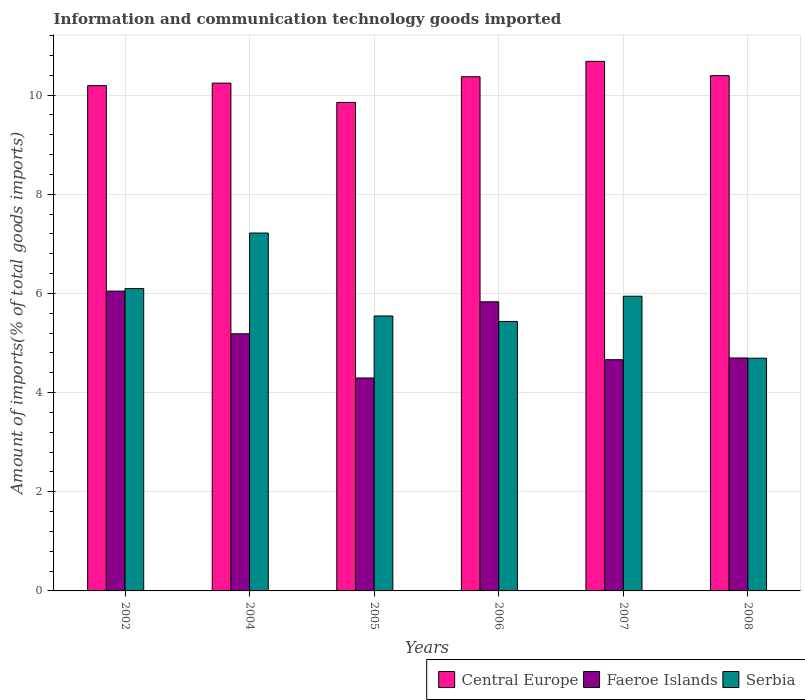Are the number of bars on each tick of the X-axis equal?
Make the answer very short. Yes. How many bars are there on the 5th tick from the left?
Your answer should be compact. 3. How many bars are there on the 2nd tick from the right?
Ensure brevity in your answer.  3. What is the amount of goods imported in Central Europe in 2005?
Provide a succinct answer. 9.85. Across all years, what is the maximum amount of goods imported in Central Europe?
Offer a very short reply. 10.68. Across all years, what is the minimum amount of goods imported in Faeroe Islands?
Give a very brief answer. 4.29. In which year was the amount of goods imported in Central Europe maximum?
Offer a very short reply. 2007. What is the total amount of goods imported in Serbia in the graph?
Your answer should be very brief. 34.94. What is the difference between the amount of goods imported in Faeroe Islands in 2007 and that in 2008?
Provide a short and direct response. -0.04. What is the difference between the amount of goods imported in Serbia in 2008 and the amount of goods imported in Central Europe in 2005?
Ensure brevity in your answer.  -5.16. What is the average amount of goods imported in Faeroe Islands per year?
Provide a short and direct response. 5.12. In the year 2006, what is the difference between the amount of goods imported in Faeroe Islands and amount of goods imported in Central Europe?
Make the answer very short. -4.54. In how many years, is the amount of goods imported in Serbia greater than 4.4 %?
Your answer should be very brief. 6. What is the ratio of the amount of goods imported in Serbia in 2006 to that in 2007?
Keep it short and to the point. 0.91. What is the difference between the highest and the second highest amount of goods imported in Serbia?
Your answer should be compact. 1.12. What is the difference between the highest and the lowest amount of goods imported in Central Europe?
Your response must be concise. 0.83. Is the sum of the amount of goods imported in Central Europe in 2002 and 2005 greater than the maximum amount of goods imported in Faeroe Islands across all years?
Keep it short and to the point. Yes. What does the 1st bar from the left in 2006 represents?
Provide a succinct answer. Central Europe. What does the 3rd bar from the right in 2002 represents?
Your answer should be compact. Central Europe. How many bars are there?
Provide a short and direct response. 18. What is the difference between two consecutive major ticks on the Y-axis?
Keep it short and to the point. 2. Does the graph contain grids?
Provide a succinct answer. Yes. Where does the legend appear in the graph?
Give a very brief answer. Bottom right. What is the title of the graph?
Provide a short and direct response. Information and communication technology goods imported. Does "Malta" appear as one of the legend labels in the graph?
Ensure brevity in your answer.  No. What is the label or title of the Y-axis?
Your answer should be compact. Amount of imports(% of total goods imports). What is the Amount of imports(% of total goods imports) of Central Europe in 2002?
Your response must be concise. 10.19. What is the Amount of imports(% of total goods imports) of Faeroe Islands in 2002?
Provide a succinct answer. 6.05. What is the Amount of imports(% of total goods imports) of Serbia in 2002?
Ensure brevity in your answer.  6.1. What is the Amount of imports(% of total goods imports) in Central Europe in 2004?
Make the answer very short. 10.24. What is the Amount of imports(% of total goods imports) of Faeroe Islands in 2004?
Provide a short and direct response. 5.19. What is the Amount of imports(% of total goods imports) in Serbia in 2004?
Your response must be concise. 7.22. What is the Amount of imports(% of total goods imports) of Central Europe in 2005?
Ensure brevity in your answer.  9.85. What is the Amount of imports(% of total goods imports) in Faeroe Islands in 2005?
Your answer should be very brief. 4.29. What is the Amount of imports(% of total goods imports) in Serbia in 2005?
Make the answer very short. 5.55. What is the Amount of imports(% of total goods imports) in Central Europe in 2006?
Offer a terse response. 10.37. What is the Amount of imports(% of total goods imports) in Faeroe Islands in 2006?
Make the answer very short. 5.83. What is the Amount of imports(% of total goods imports) of Serbia in 2006?
Your response must be concise. 5.44. What is the Amount of imports(% of total goods imports) of Central Europe in 2007?
Provide a short and direct response. 10.68. What is the Amount of imports(% of total goods imports) in Faeroe Islands in 2007?
Offer a very short reply. 4.66. What is the Amount of imports(% of total goods imports) of Serbia in 2007?
Your answer should be very brief. 5.94. What is the Amount of imports(% of total goods imports) of Central Europe in 2008?
Offer a very short reply. 10.39. What is the Amount of imports(% of total goods imports) in Faeroe Islands in 2008?
Offer a terse response. 4.7. What is the Amount of imports(% of total goods imports) of Serbia in 2008?
Your answer should be compact. 4.69. Across all years, what is the maximum Amount of imports(% of total goods imports) in Central Europe?
Your response must be concise. 10.68. Across all years, what is the maximum Amount of imports(% of total goods imports) in Faeroe Islands?
Ensure brevity in your answer.  6.05. Across all years, what is the maximum Amount of imports(% of total goods imports) of Serbia?
Keep it short and to the point. 7.22. Across all years, what is the minimum Amount of imports(% of total goods imports) in Central Europe?
Offer a very short reply. 9.85. Across all years, what is the minimum Amount of imports(% of total goods imports) in Faeroe Islands?
Your answer should be compact. 4.29. Across all years, what is the minimum Amount of imports(% of total goods imports) in Serbia?
Your response must be concise. 4.69. What is the total Amount of imports(% of total goods imports) of Central Europe in the graph?
Provide a short and direct response. 61.73. What is the total Amount of imports(% of total goods imports) in Faeroe Islands in the graph?
Ensure brevity in your answer.  30.72. What is the total Amount of imports(% of total goods imports) in Serbia in the graph?
Provide a succinct answer. 34.94. What is the difference between the Amount of imports(% of total goods imports) of Central Europe in 2002 and that in 2004?
Your response must be concise. -0.05. What is the difference between the Amount of imports(% of total goods imports) in Faeroe Islands in 2002 and that in 2004?
Provide a succinct answer. 0.86. What is the difference between the Amount of imports(% of total goods imports) in Serbia in 2002 and that in 2004?
Provide a short and direct response. -1.12. What is the difference between the Amount of imports(% of total goods imports) in Central Europe in 2002 and that in 2005?
Your answer should be very brief. 0.34. What is the difference between the Amount of imports(% of total goods imports) of Faeroe Islands in 2002 and that in 2005?
Offer a terse response. 1.75. What is the difference between the Amount of imports(% of total goods imports) of Serbia in 2002 and that in 2005?
Your answer should be compact. 0.55. What is the difference between the Amount of imports(% of total goods imports) of Central Europe in 2002 and that in 2006?
Provide a succinct answer. -0.18. What is the difference between the Amount of imports(% of total goods imports) in Faeroe Islands in 2002 and that in 2006?
Provide a short and direct response. 0.22. What is the difference between the Amount of imports(% of total goods imports) in Serbia in 2002 and that in 2006?
Give a very brief answer. 0.66. What is the difference between the Amount of imports(% of total goods imports) of Central Europe in 2002 and that in 2007?
Make the answer very short. -0.49. What is the difference between the Amount of imports(% of total goods imports) of Faeroe Islands in 2002 and that in 2007?
Your answer should be very brief. 1.38. What is the difference between the Amount of imports(% of total goods imports) of Serbia in 2002 and that in 2007?
Your answer should be very brief. 0.15. What is the difference between the Amount of imports(% of total goods imports) in Central Europe in 2002 and that in 2008?
Your answer should be compact. -0.2. What is the difference between the Amount of imports(% of total goods imports) of Faeroe Islands in 2002 and that in 2008?
Provide a short and direct response. 1.35. What is the difference between the Amount of imports(% of total goods imports) of Serbia in 2002 and that in 2008?
Your answer should be very brief. 1.4. What is the difference between the Amount of imports(% of total goods imports) of Central Europe in 2004 and that in 2005?
Ensure brevity in your answer.  0.39. What is the difference between the Amount of imports(% of total goods imports) in Faeroe Islands in 2004 and that in 2005?
Provide a short and direct response. 0.89. What is the difference between the Amount of imports(% of total goods imports) of Serbia in 2004 and that in 2005?
Keep it short and to the point. 1.67. What is the difference between the Amount of imports(% of total goods imports) of Central Europe in 2004 and that in 2006?
Keep it short and to the point. -0.13. What is the difference between the Amount of imports(% of total goods imports) in Faeroe Islands in 2004 and that in 2006?
Ensure brevity in your answer.  -0.65. What is the difference between the Amount of imports(% of total goods imports) in Serbia in 2004 and that in 2006?
Provide a succinct answer. 1.78. What is the difference between the Amount of imports(% of total goods imports) of Central Europe in 2004 and that in 2007?
Your answer should be very brief. -0.44. What is the difference between the Amount of imports(% of total goods imports) of Faeroe Islands in 2004 and that in 2007?
Keep it short and to the point. 0.52. What is the difference between the Amount of imports(% of total goods imports) of Serbia in 2004 and that in 2007?
Your answer should be very brief. 1.27. What is the difference between the Amount of imports(% of total goods imports) of Central Europe in 2004 and that in 2008?
Keep it short and to the point. -0.15. What is the difference between the Amount of imports(% of total goods imports) in Faeroe Islands in 2004 and that in 2008?
Your response must be concise. 0.49. What is the difference between the Amount of imports(% of total goods imports) in Serbia in 2004 and that in 2008?
Keep it short and to the point. 2.52. What is the difference between the Amount of imports(% of total goods imports) of Central Europe in 2005 and that in 2006?
Your response must be concise. -0.52. What is the difference between the Amount of imports(% of total goods imports) in Faeroe Islands in 2005 and that in 2006?
Offer a very short reply. -1.54. What is the difference between the Amount of imports(% of total goods imports) of Serbia in 2005 and that in 2006?
Your answer should be very brief. 0.11. What is the difference between the Amount of imports(% of total goods imports) of Central Europe in 2005 and that in 2007?
Ensure brevity in your answer.  -0.83. What is the difference between the Amount of imports(% of total goods imports) of Faeroe Islands in 2005 and that in 2007?
Give a very brief answer. -0.37. What is the difference between the Amount of imports(% of total goods imports) in Serbia in 2005 and that in 2007?
Offer a terse response. -0.4. What is the difference between the Amount of imports(% of total goods imports) of Central Europe in 2005 and that in 2008?
Your answer should be very brief. -0.54. What is the difference between the Amount of imports(% of total goods imports) of Faeroe Islands in 2005 and that in 2008?
Make the answer very short. -0.4. What is the difference between the Amount of imports(% of total goods imports) in Serbia in 2005 and that in 2008?
Provide a short and direct response. 0.85. What is the difference between the Amount of imports(% of total goods imports) in Central Europe in 2006 and that in 2007?
Your answer should be very brief. -0.31. What is the difference between the Amount of imports(% of total goods imports) in Faeroe Islands in 2006 and that in 2007?
Keep it short and to the point. 1.17. What is the difference between the Amount of imports(% of total goods imports) in Serbia in 2006 and that in 2007?
Your answer should be compact. -0.51. What is the difference between the Amount of imports(% of total goods imports) in Central Europe in 2006 and that in 2008?
Keep it short and to the point. -0.02. What is the difference between the Amount of imports(% of total goods imports) of Faeroe Islands in 2006 and that in 2008?
Your answer should be compact. 1.13. What is the difference between the Amount of imports(% of total goods imports) of Serbia in 2006 and that in 2008?
Provide a succinct answer. 0.74. What is the difference between the Amount of imports(% of total goods imports) in Central Europe in 2007 and that in 2008?
Your response must be concise. 0.29. What is the difference between the Amount of imports(% of total goods imports) in Faeroe Islands in 2007 and that in 2008?
Make the answer very short. -0.04. What is the difference between the Amount of imports(% of total goods imports) of Serbia in 2007 and that in 2008?
Offer a terse response. 1.25. What is the difference between the Amount of imports(% of total goods imports) in Central Europe in 2002 and the Amount of imports(% of total goods imports) in Faeroe Islands in 2004?
Offer a very short reply. 5. What is the difference between the Amount of imports(% of total goods imports) in Central Europe in 2002 and the Amount of imports(% of total goods imports) in Serbia in 2004?
Make the answer very short. 2.97. What is the difference between the Amount of imports(% of total goods imports) in Faeroe Islands in 2002 and the Amount of imports(% of total goods imports) in Serbia in 2004?
Keep it short and to the point. -1.17. What is the difference between the Amount of imports(% of total goods imports) in Central Europe in 2002 and the Amount of imports(% of total goods imports) in Faeroe Islands in 2005?
Your answer should be compact. 5.9. What is the difference between the Amount of imports(% of total goods imports) of Central Europe in 2002 and the Amount of imports(% of total goods imports) of Serbia in 2005?
Offer a terse response. 4.65. What is the difference between the Amount of imports(% of total goods imports) of Faeroe Islands in 2002 and the Amount of imports(% of total goods imports) of Serbia in 2005?
Make the answer very short. 0.5. What is the difference between the Amount of imports(% of total goods imports) of Central Europe in 2002 and the Amount of imports(% of total goods imports) of Faeroe Islands in 2006?
Your answer should be very brief. 4.36. What is the difference between the Amount of imports(% of total goods imports) in Central Europe in 2002 and the Amount of imports(% of total goods imports) in Serbia in 2006?
Keep it short and to the point. 4.76. What is the difference between the Amount of imports(% of total goods imports) in Faeroe Islands in 2002 and the Amount of imports(% of total goods imports) in Serbia in 2006?
Your response must be concise. 0.61. What is the difference between the Amount of imports(% of total goods imports) in Central Europe in 2002 and the Amount of imports(% of total goods imports) in Faeroe Islands in 2007?
Your answer should be very brief. 5.53. What is the difference between the Amount of imports(% of total goods imports) of Central Europe in 2002 and the Amount of imports(% of total goods imports) of Serbia in 2007?
Provide a succinct answer. 4.25. What is the difference between the Amount of imports(% of total goods imports) of Faeroe Islands in 2002 and the Amount of imports(% of total goods imports) of Serbia in 2007?
Make the answer very short. 0.1. What is the difference between the Amount of imports(% of total goods imports) in Central Europe in 2002 and the Amount of imports(% of total goods imports) in Faeroe Islands in 2008?
Your answer should be compact. 5.49. What is the difference between the Amount of imports(% of total goods imports) of Central Europe in 2002 and the Amount of imports(% of total goods imports) of Serbia in 2008?
Your answer should be very brief. 5.5. What is the difference between the Amount of imports(% of total goods imports) in Faeroe Islands in 2002 and the Amount of imports(% of total goods imports) in Serbia in 2008?
Give a very brief answer. 1.35. What is the difference between the Amount of imports(% of total goods imports) in Central Europe in 2004 and the Amount of imports(% of total goods imports) in Faeroe Islands in 2005?
Make the answer very short. 5.95. What is the difference between the Amount of imports(% of total goods imports) of Central Europe in 2004 and the Amount of imports(% of total goods imports) of Serbia in 2005?
Ensure brevity in your answer.  4.7. What is the difference between the Amount of imports(% of total goods imports) of Faeroe Islands in 2004 and the Amount of imports(% of total goods imports) of Serbia in 2005?
Your answer should be very brief. -0.36. What is the difference between the Amount of imports(% of total goods imports) of Central Europe in 2004 and the Amount of imports(% of total goods imports) of Faeroe Islands in 2006?
Provide a succinct answer. 4.41. What is the difference between the Amount of imports(% of total goods imports) in Central Europe in 2004 and the Amount of imports(% of total goods imports) in Serbia in 2006?
Your answer should be very brief. 4.81. What is the difference between the Amount of imports(% of total goods imports) of Faeroe Islands in 2004 and the Amount of imports(% of total goods imports) of Serbia in 2006?
Ensure brevity in your answer.  -0.25. What is the difference between the Amount of imports(% of total goods imports) in Central Europe in 2004 and the Amount of imports(% of total goods imports) in Faeroe Islands in 2007?
Ensure brevity in your answer.  5.58. What is the difference between the Amount of imports(% of total goods imports) in Central Europe in 2004 and the Amount of imports(% of total goods imports) in Serbia in 2007?
Your answer should be very brief. 4.3. What is the difference between the Amount of imports(% of total goods imports) of Faeroe Islands in 2004 and the Amount of imports(% of total goods imports) of Serbia in 2007?
Give a very brief answer. -0.76. What is the difference between the Amount of imports(% of total goods imports) of Central Europe in 2004 and the Amount of imports(% of total goods imports) of Faeroe Islands in 2008?
Your answer should be very brief. 5.54. What is the difference between the Amount of imports(% of total goods imports) of Central Europe in 2004 and the Amount of imports(% of total goods imports) of Serbia in 2008?
Provide a short and direct response. 5.55. What is the difference between the Amount of imports(% of total goods imports) in Faeroe Islands in 2004 and the Amount of imports(% of total goods imports) in Serbia in 2008?
Provide a succinct answer. 0.49. What is the difference between the Amount of imports(% of total goods imports) of Central Europe in 2005 and the Amount of imports(% of total goods imports) of Faeroe Islands in 2006?
Ensure brevity in your answer.  4.02. What is the difference between the Amount of imports(% of total goods imports) in Central Europe in 2005 and the Amount of imports(% of total goods imports) in Serbia in 2006?
Offer a very short reply. 4.42. What is the difference between the Amount of imports(% of total goods imports) in Faeroe Islands in 2005 and the Amount of imports(% of total goods imports) in Serbia in 2006?
Give a very brief answer. -1.14. What is the difference between the Amount of imports(% of total goods imports) in Central Europe in 2005 and the Amount of imports(% of total goods imports) in Faeroe Islands in 2007?
Provide a succinct answer. 5.19. What is the difference between the Amount of imports(% of total goods imports) in Central Europe in 2005 and the Amount of imports(% of total goods imports) in Serbia in 2007?
Your answer should be very brief. 3.91. What is the difference between the Amount of imports(% of total goods imports) in Faeroe Islands in 2005 and the Amount of imports(% of total goods imports) in Serbia in 2007?
Keep it short and to the point. -1.65. What is the difference between the Amount of imports(% of total goods imports) of Central Europe in 2005 and the Amount of imports(% of total goods imports) of Faeroe Islands in 2008?
Your answer should be compact. 5.15. What is the difference between the Amount of imports(% of total goods imports) of Central Europe in 2005 and the Amount of imports(% of total goods imports) of Serbia in 2008?
Keep it short and to the point. 5.16. What is the difference between the Amount of imports(% of total goods imports) of Faeroe Islands in 2005 and the Amount of imports(% of total goods imports) of Serbia in 2008?
Give a very brief answer. -0.4. What is the difference between the Amount of imports(% of total goods imports) in Central Europe in 2006 and the Amount of imports(% of total goods imports) in Faeroe Islands in 2007?
Offer a terse response. 5.71. What is the difference between the Amount of imports(% of total goods imports) of Central Europe in 2006 and the Amount of imports(% of total goods imports) of Serbia in 2007?
Your answer should be very brief. 4.43. What is the difference between the Amount of imports(% of total goods imports) of Faeroe Islands in 2006 and the Amount of imports(% of total goods imports) of Serbia in 2007?
Your answer should be very brief. -0.11. What is the difference between the Amount of imports(% of total goods imports) in Central Europe in 2006 and the Amount of imports(% of total goods imports) in Faeroe Islands in 2008?
Keep it short and to the point. 5.67. What is the difference between the Amount of imports(% of total goods imports) in Central Europe in 2006 and the Amount of imports(% of total goods imports) in Serbia in 2008?
Make the answer very short. 5.68. What is the difference between the Amount of imports(% of total goods imports) in Faeroe Islands in 2006 and the Amount of imports(% of total goods imports) in Serbia in 2008?
Provide a succinct answer. 1.14. What is the difference between the Amount of imports(% of total goods imports) in Central Europe in 2007 and the Amount of imports(% of total goods imports) in Faeroe Islands in 2008?
Give a very brief answer. 5.98. What is the difference between the Amount of imports(% of total goods imports) of Central Europe in 2007 and the Amount of imports(% of total goods imports) of Serbia in 2008?
Make the answer very short. 5.99. What is the difference between the Amount of imports(% of total goods imports) in Faeroe Islands in 2007 and the Amount of imports(% of total goods imports) in Serbia in 2008?
Make the answer very short. -0.03. What is the average Amount of imports(% of total goods imports) in Central Europe per year?
Keep it short and to the point. 10.29. What is the average Amount of imports(% of total goods imports) in Faeroe Islands per year?
Give a very brief answer. 5.12. What is the average Amount of imports(% of total goods imports) of Serbia per year?
Your answer should be compact. 5.82. In the year 2002, what is the difference between the Amount of imports(% of total goods imports) of Central Europe and Amount of imports(% of total goods imports) of Faeroe Islands?
Give a very brief answer. 4.14. In the year 2002, what is the difference between the Amount of imports(% of total goods imports) in Central Europe and Amount of imports(% of total goods imports) in Serbia?
Provide a short and direct response. 4.09. In the year 2002, what is the difference between the Amount of imports(% of total goods imports) of Faeroe Islands and Amount of imports(% of total goods imports) of Serbia?
Provide a short and direct response. -0.05. In the year 2004, what is the difference between the Amount of imports(% of total goods imports) of Central Europe and Amount of imports(% of total goods imports) of Faeroe Islands?
Make the answer very short. 5.06. In the year 2004, what is the difference between the Amount of imports(% of total goods imports) of Central Europe and Amount of imports(% of total goods imports) of Serbia?
Your answer should be compact. 3.02. In the year 2004, what is the difference between the Amount of imports(% of total goods imports) of Faeroe Islands and Amount of imports(% of total goods imports) of Serbia?
Ensure brevity in your answer.  -2.03. In the year 2005, what is the difference between the Amount of imports(% of total goods imports) in Central Europe and Amount of imports(% of total goods imports) in Faeroe Islands?
Provide a succinct answer. 5.56. In the year 2005, what is the difference between the Amount of imports(% of total goods imports) of Central Europe and Amount of imports(% of total goods imports) of Serbia?
Make the answer very short. 4.31. In the year 2005, what is the difference between the Amount of imports(% of total goods imports) of Faeroe Islands and Amount of imports(% of total goods imports) of Serbia?
Provide a short and direct response. -1.25. In the year 2006, what is the difference between the Amount of imports(% of total goods imports) of Central Europe and Amount of imports(% of total goods imports) of Faeroe Islands?
Offer a terse response. 4.54. In the year 2006, what is the difference between the Amount of imports(% of total goods imports) of Central Europe and Amount of imports(% of total goods imports) of Serbia?
Offer a very short reply. 4.94. In the year 2006, what is the difference between the Amount of imports(% of total goods imports) in Faeroe Islands and Amount of imports(% of total goods imports) in Serbia?
Ensure brevity in your answer.  0.4. In the year 2007, what is the difference between the Amount of imports(% of total goods imports) in Central Europe and Amount of imports(% of total goods imports) in Faeroe Islands?
Your response must be concise. 6.02. In the year 2007, what is the difference between the Amount of imports(% of total goods imports) of Central Europe and Amount of imports(% of total goods imports) of Serbia?
Your response must be concise. 4.74. In the year 2007, what is the difference between the Amount of imports(% of total goods imports) in Faeroe Islands and Amount of imports(% of total goods imports) in Serbia?
Ensure brevity in your answer.  -1.28. In the year 2008, what is the difference between the Amount of imports(% of total goods imports) in Central Europe and Amount of imports(% of total goods imports) in Faeroe Islands?
Your response must be concise. 5.69. In the year 2008, what is the difference between the Amount of imports(% of total goods imports) of Central Europe and Amount of imports(% of total goods imports) of Serbia?
Offer a terse response. 5.7. In the year 2008, what is the difference between the Amount of imports(% of total goods imports) in Faeroe Islands and Amount of imports(% of total goods imports) in Serbia?
Your answer should be very brief. 0. What is the ratio of the Amount of imports(% of total goods imports) in Faeroe Islands in 2002 to that in 2004?
Your answer should be very brief. 1.17. What is the ratio of the Amount of imports(% of total goods imports) in Serbia in 2002 to that in 2004?
Give a very brief answer. 0.84. What is the ratio of the Amount of imports(% of total goods imports) in Central Europe in 2002 to that in 2005?
Keep it short and to the point. 1.03. What is the ratio of the Amount of imports(% of total goods imports) of Faeroe Islands in 2002 to that in 2005?
Give a very brief answer. 1.41. What is the ratio of the Amount of imports(% of total goods imports) of Serbia in 2002 to that in 2005?
Your response must be concise. 1.1. What is the ratio of the Amount of imports(% of total goods imports) of Central Europe in 2002 to that in 2006?
Offer a very short reply. 0.98. What is the ratio of the Amount of imports(% of total goods imports) in Faeroe Islands in 2002 to that in 2006?
Offer a very short reply. 1.04. What is the ratio of the Amount of imports(% of total goods imports) in Serbia in 2002 to that in 2006?
Keep it short and to the point. 1.12. What is the ratio of the Amount of imports(% of total goods imports) in Central Europe in 2002 to that in 2007?
Your response must be concise. 0.95. What is the ratio of the Amount of imports(% of total goods imports) in Faeroe Islands in 2002 to that in 2007?
Offer a terse response. 1.3. What is the ratio of the Amount of imports(% of total goods imports) of Serbia in 2002 to that in 2007?
Provide a short and direct response. 1.03. What is the ratio of the Amount of imports(% of total goods imports) in Central Europe in 2002 to that in 2008?
Give a very brief answer. 0.98. What is the ratio of the Amount of imports(% of total goods imports) in Faeroe Islands in 2002 to that in 2008?
Provide a succinct answer. 1.29. What is the ratio of the Amount of imports(% of total goods imports) in Serbia in 2002 to that in 2008?
Provide a succinct answer. 1.3. What is the ratio of the Amount of imports(% of total goods imports) of Central Europe in 2004 to that in 2005?
Make the answer very short. 1.04. What is the ratio of the Amount of imports(% of total goods imports) of Faeroe Islands in 2004 to that in 2005?
Offer a very short reply. 1.21. What is the ratio of the Amount of imports(% of total goods imports) of Serbia in 2004 to that in 2005?
Offer a terse response. 1.3. What is the ratio of the Amount of imports(% of total goods imports) of Central Europe in 2004 to that in 2006?
Your answer should be compact. 0.99. What is the ratio of the Amount of imports(% of total goods imports) of Faeroe Islands in 2004 to that in 2006?
Your answer should be very brief. 0.89. What is the ratio of the Amount of imports(% of total goods imports) of Serbia in 2004 to that in 2006?
Your answer should be compact. 1.33. What is the ratio of the Amount of imports(% of total goods imports) of Central Europe in 2004 to that in 2007?
Provide a short and direct response. 0.96. What is the ratio of the Amount of imports(% of total goods imports) in Faeroe Islands in 2004 to that in 2007?
Your answer should be compact. 1.11. What is the ratio of the Amount of imports(% of total goods imports) of Serbia in 2004 to that in 2007?
Offer a terse response. 1.21. What is the ratio of the Amount of imports(% of total goods imports) in Central Europe in 2004 to that in 2008?
Keep it short and to the point. 0.99. What is the ratio of the Amount of imports(% of total goods imports) in Faeroe Islands in 2004 to that in 2008?
Ensure brevity in your answer.  1.1. What is the ratio of the Amount of imports(% of total goods imports) of Serbia in 2004 to that in 2008?
Make the answer very short. 1.54. What is the ratio of the Amount of imports(% of total goods imports) of Faeroe Islands in 2005 to that in 2006?
Your response must be concise. 0.74. What is the ratio of the Amount of imports(% of total goods imports) in Serbia in 2005 to that in 2006?
Ensure brevity in your answer.  1.02. What is the ratio of the Amount of imports(% of total goods imports) in Central Europe in 2005 to that in 2007?
Make the answer very short. 0.92. What is the ratio of the Amount of imports(% of total goods imports) of Faeroe Islands in 2005 to that in 2007?
Offer a terse response. 0.92. What is the ratio of the Amount of imports(% of total goods imports) in Serbia in 2005 to that in 2007?
Make the answer very short. 0.93. What is the ratio of the Amount of imports(% of total goods imports) in Central Europe in 2005 to that in 2008?
Offer a very short reply. 0.95. What is the ratio of the Amount of imports(% of total goods imports) in Faeroe Islands in 2005 to that in 2008?
Offer a very short reply. 0.91. What is the ratio of the Amount of imports(% of total goods imports) of Serbia in 2005 to that in 2008?
Ensure brevity in your answer.  1.18. What is the ratio of the Amount of imports(% of total goods imports) of Faeroe Islands in 2006 to that in 2007?
Make the answer very short. 1.25. What is the ratio of the Amount of imports(% of total goods imports) of Serbia in 2006 to that in 2007?
Your answer should be very brief. 0.91. What is the ratio of the Amount of imports(% of total goods imports) of Central Europe in 2006 to that in 2008?
Keep it short and to the point. 1. What is the ratio of the Amount of imports(% of total goods imports) of Faeroe Islands in 2006 to that in 2008?
Give a very brief answer. 1.24. What is the ratio of the Amount of imports(% of total goods imports) of Serbia in 2006 to that in 2008?
Your response must be concise. 1.16. What is the ratio of the Amount of imports(% of total goods imports) in Central Europe in 2007 to that in 2008?
Provide a short and direct response. 1.03. What is the ratio of the Amount of imports(% of total goods imports) of Faeroe Islands in 2007 to that in 2008?
Offer a terse response. 0.99. What is the ratio of the Amount of imports(% of total goods imports) of Serbia in 2007 to that in 2008?
Keep it short and to the point. 1.27. What is the difference between the highest and the second highest Amount of imports(% of total goods imports) of Central Europe?
Offer a terse response. 0.29. What is the difference between the highest and the second highest Amount of imports(% of total goods imports) in Faeroe Islands?
Your response must be concise. 0.22. What is the difference between the highest and the second highest Amount of imports(% of total goods imports) in Serbia?
Keep it short and to the point. 1.12. What is the difference between the highest and the lowest Amount of imports(% of total goods imports) in Central Europe?
Ensure brevity in your answer.  0.83. What is the difference between the highest and the lowest Amount of imports(% of total goods imports) in Faeroe Islands?
Offer a very short reply. 1.75. What is the difference between the highest and the lowest Amount of imports(% of total goods imports) in Serbia?
Your answer should be compact. 2.52. 